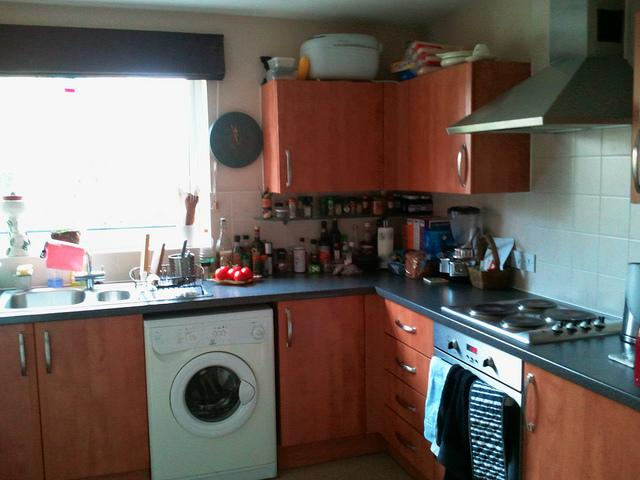What material is the sink made of? steel 